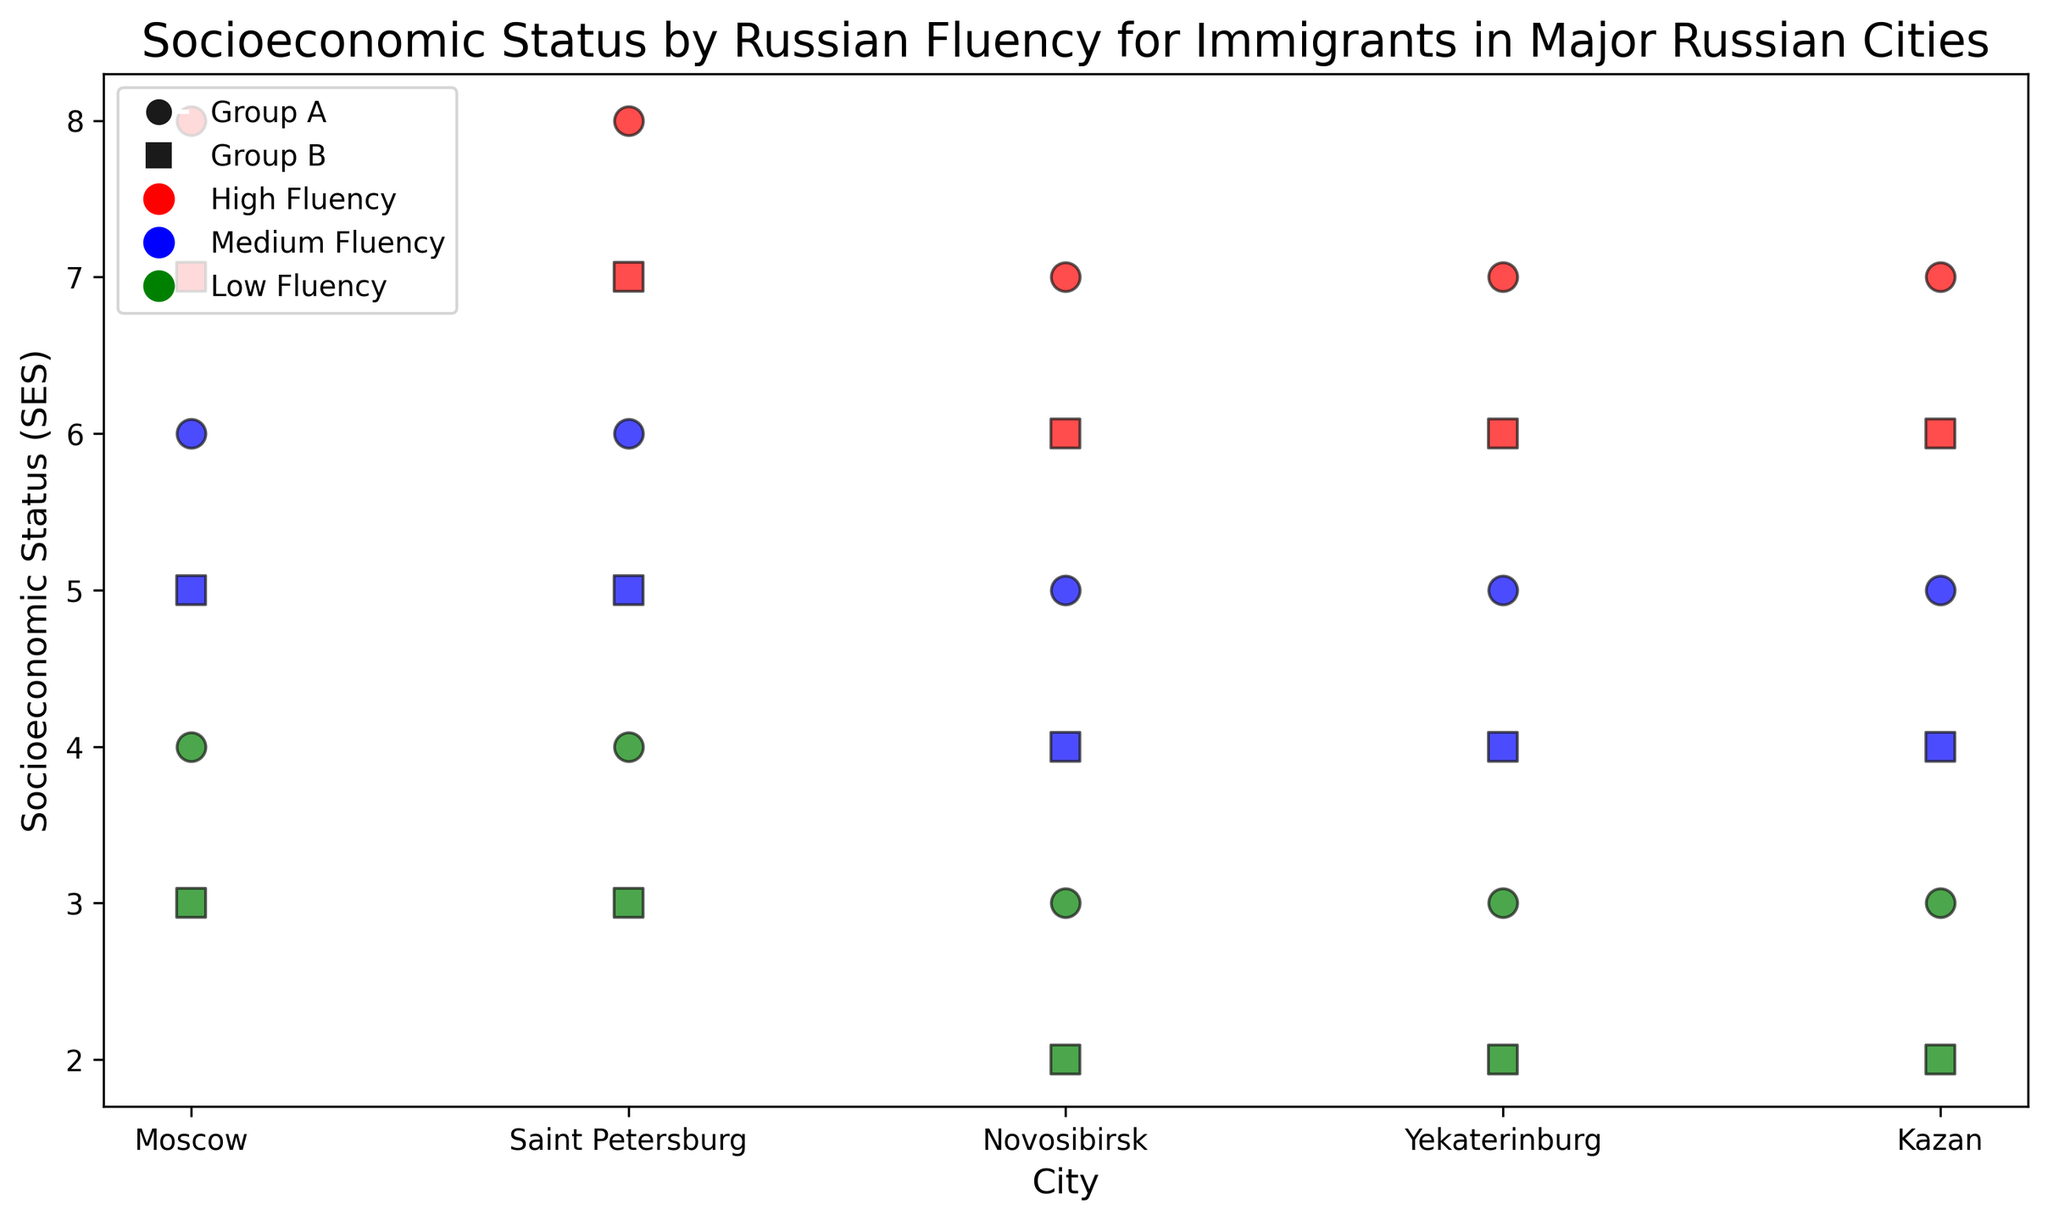What is the socioeconomic status for Group A with high fluency in Moscow? Find the red circle marker in the plot for Moscow, which represents Group A with high fluency. The y-value of this marker indicates the socioeconomic status.
Answer: 8 Which immigrant group has a higher socioeconomic status in Kazan for the medium fluency level? Compare the blue circle and square markers in Kazan. The y-value of these markers represents the socioeconomic status for Group A and Group B with medium fluency. Group A has a value of 5, and Group B has a value of 4.
Answer: Group A What is the difference in socioeconomic status between Group A and Group B with low fluency in Novosibirsk? Identify the green circle (Group A) and the green square (Group B) markers in Novosibirsk. The y-values are 3 for Group A and 2 for Group B. Subtract the values for Group B from Group A.
Answer: 1 Which city has the lowest socioeconomic status for Group B with high fluency? Examine all cities' red square markers, which represent Group B with high fluency. Identify the city with the lowest y-value. Novosibirsk and Yekaterinburg both have y-values of 6.
Answer: Novosibirsk and Yekaterinburg How does socioeconomic status vary for Group A across all cities? Look at the red, blue, and green circle markers for Group A across all cities to observe SES values. Note variations and range. SES values are 8, 6, and 4 for Moscow and Saint Petersburg, 7, 5, and 3 for Novosibirsk, Yekaterinburg, and Kazan.
Answer: SES varies from 3 to 8 Which fluency level corresponds to the highest socioeconomic status in Yekaterinburg for both groups? Find markers in Yekaterinburg for both groups and compare their corresponding y-values (SES). High fluency has the highest SES for both groups at 7 and 6.
Answer: High fluency level Between Moscow and Saint Petersburg, which city has a higher SES for Group A with medium fluency? Compare the blue circle markers (Group A with medium fluency) for Moscow and Saint Petersburg. Both cities have a y-value of 6.
Answer: Same in both cities What is the average socioeconomic status for Group B across all cities at high fluency? Locate red square markers for Group B in all cities. Add their SES values (7 + 7 + 6 + 6 + 6) and divide by the number of cities (5). Calculation: (7+7+6+6+6)/5 = 32/5 = 6.4.
Answer: 6.4 Is there a difference in socioeconomic status between high and low fluency for Group A in Saint Petersburg? Compare the SES values of red (high) and green (low) circle markers for Group A in Saint Petersburg. Values are 8 for high and 4 for low fluency.
Answer: Yes Which group has lower socioeconomic status in Yekaterinburg with low fluency, Group A or Group B? Compare the green circle (Group A) and green square (Group B) markers in Yekaterinburg. Group A has a value of 3, and Group B has a value of 2.
Answer: Group B 